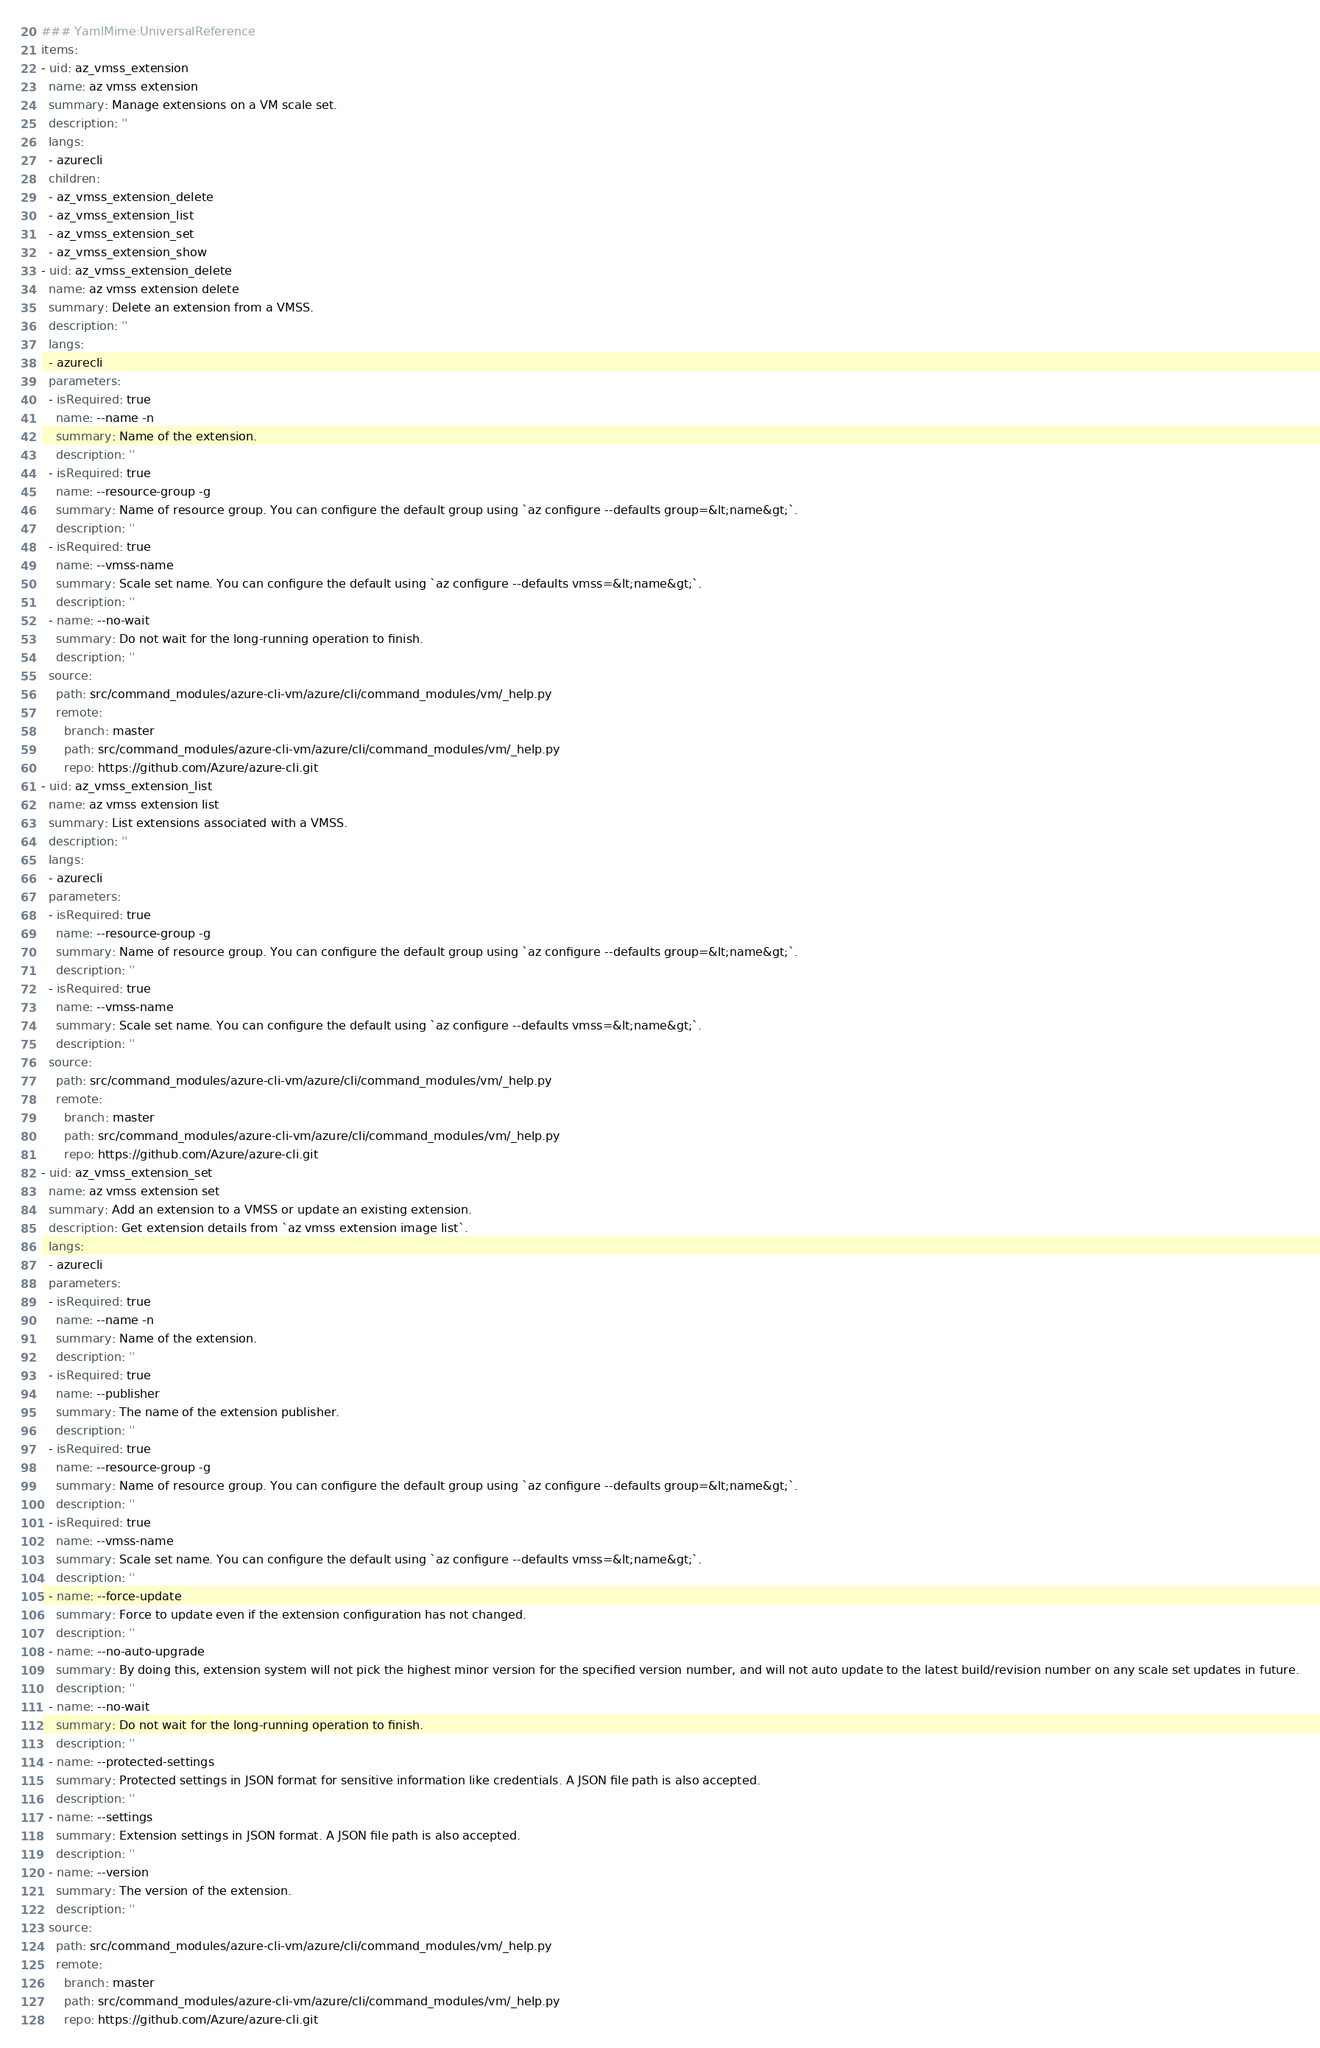Convert code to text. <code><loc_0><loc_0><loc_500><loc_500><_YAML_>### YamlMime:UniversalReference
items:
- uid: az_vmss_extension
  name: az vmss extension
  summary: Manage extensions on a VM scale set.
  description: ''
  langs:
  - azurecli
  children:
  - az_vmss_extension_delete
  - az_vmss_extension_list
  - az_vmss_extension_set
  - az_vmss_extension_show
- uid: az_vmss_extension_delete
  name: az vmss extension delete
  summary: Delete an extension from a VMSS.
  description: ''
  langs:
  - azurecli
  parameters:
  - isRequired: true
    name: --name -n
    summary: Name of the extension.
    description: ''
  - isRequired: true
    name: --resource-group -g
    summary: Name of resource group. You can configure the default group using `az configure --defaults group=&lt;name&gt;`.
    description: ''
  - isRequired: true
    name: --vmss-name
    summary: Scale set name. You can configure the default using `az configure --defaults vmss=&lt;name&gt;`.
    description: ''
  - name: --no-wait
    summary: Do not wait for the long-running operation to finish.
    description: ''
  source:
    path: src/command_modules/azure-cli-vm/azure/cli/command_modules/vm/_help.py
    remote:
      branch: master
      path: src/command_modules/azure-cli-vm/azure/cli/command_modules/vm/_help.py
      repo: https://github.com/Azure/azure-cli.git
- uid: az_vmss_extension_list
  name: az vmss extension list
  summary: List extensions associated with a VMSS.
  description: ''
  langs:
  - azurecli
  parameters:
  - isRequired: true
    name: --resource-group -g
    summary: Name of resource group. You can configure the default group using `az configure --defaults group=&lt;name&gt;`.
    description: ''
  - isRequired: true
    name: --vmss-name
    summary: Scale set name. You can configure the default using `az configure --defaults vmss=&lt;name&gt;`.
    description: ''
  source:
    path: src/command_modules/azure-cli-vm/azure/cli/command_modules/vm/_help.py
    remote:
      branch: master
      path: src/command_modules/azure-cli-vm/azure/cli/command_modules/vm/_help.py
      repo: https://github.com/Azure/azure-cli.git
- uid: az_vmss_extension_set
  name: az vmss extension set
  summary: Add an extension to a VMSS or update an existing extension.
  description: Get extension details from `az vmss extension image list`.
  langs:
  - azurecli
  parameters:
  - isRequired: true
    name: --name -n
    summary: Name of the extension.
    description: ''
  - isRequired: true
    name: --publisher
    summary: The name of the extension publisher.
    description: ''
  - isRequired: true
    name: --resource-group -g
    summary: Name of resource group. You can configure the default group using `az configure --defaults group=&lt;name&gt;`.
    description: ''
  - isRequired: true
    name: --vmss-name
    summary: Scale set name. You can configure the default using `az configure --defaults vmss=&lt;name&gt;`.
    description: ''
  - name: --force-update
    summary: Force to update even if the extension configuration has not changed.
    description: ''
  - name: --no-auto-upgrade
    summary: By doing this, extension system will not pick the highest minor version for the specified version number, and will not auto update to the latest build/revision number on any scale set updates in future.
    description: ''
  - name: --no-wait
    summary: Do not wait for the long-running operation to finish.
    description: ''
  - name: --protected-settings
    summary: Protected settings in JSON format for sensitive information like credentials. A JSON file path is also accepted.
    description: ''
  - name: --settings
    summary: Extension settings in JSON format. A JSON file path is also accepted.
    description: ''
  - name: --version
    summary: The version of the extension.
    description: ''
  source:
    path: src/command_modules/azure-cli-vm/azure/cli/command_modules/vm/_help.py
    remote:
      branch: master
      path: src/command_modules/azure-cli-vm/azure/cli/command_modules/vm/_help.py
      repo: https://github.com/Azure/azure-cli.git</code> 